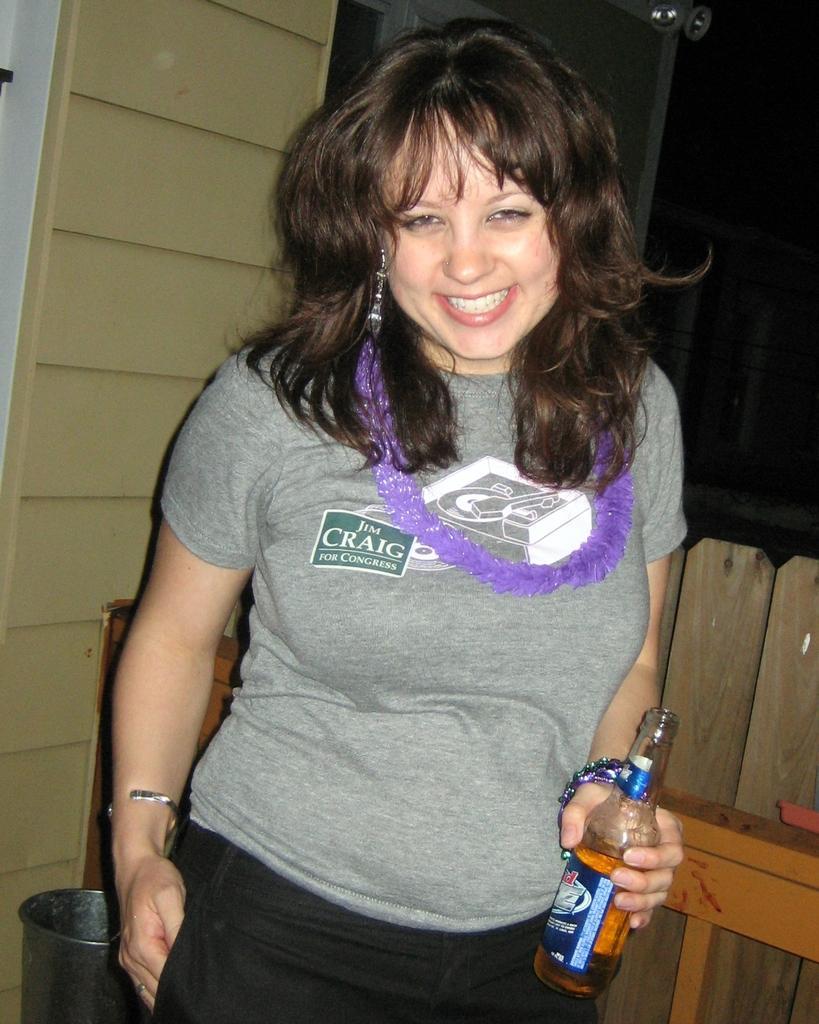Could you give a brief overview of what you see in this image? A woman is posing to camera with a wine bottle in her hand. 